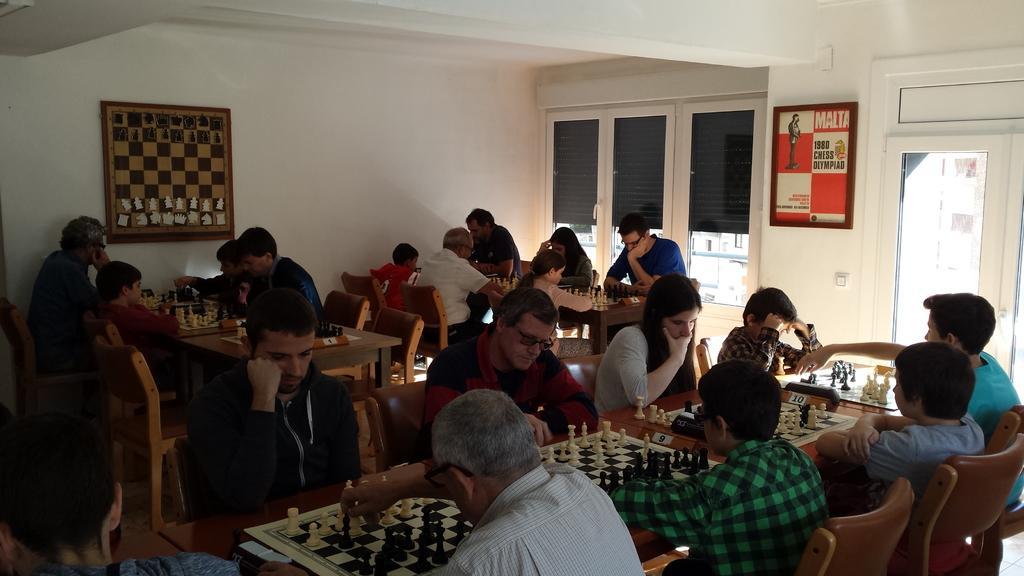In one or two sentences, can you explain what this image depicts? This is looking like a chess competition where a group of people are sitting on a chair and they are all playing a chess. 